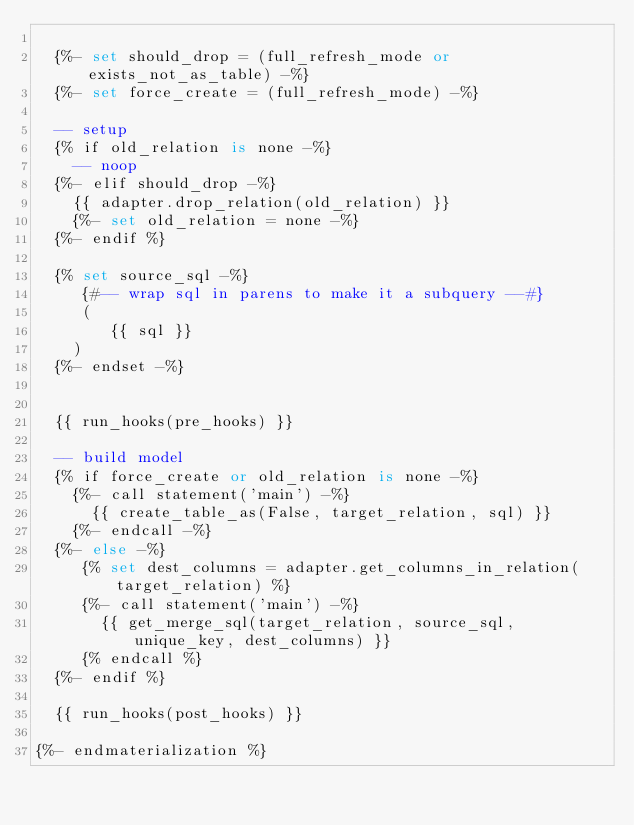Convert code to text. <code><loc_0><loc_0><loc_500><loc_500><_SQL_>
  {%- set should_drop = (full_refresh_mode or exists_not_as_table) -%}
  {%- set force_create = (full_refresh_mode) -%}

  -- setup
  {% if old_relation is none -%}
    -- noop
  {%- elif should_drop -%}
    {{ adapter.drop_relation(old_relation) }}
    {%- set old_relation = none -%}
  {%- endif %}

  {% set source_sql -%}
     {#-- wrap sql in parens to make it a subquery --#}
     (
        {{ sql }}
    )
  {%- endset -%}


  {{ run_hooks(pre_hooks) }}

  -- build model
  {% if force_create or old_relation is none -%}
    {%- call statement('main') -%}
      {{ create_table_as(False, target_relation, sql) }}
    {%- endcall -%}
  {%- else -%}
     {% set dest_columns = adapter.get_columns_in_relation(target_relation) %}
     {%- call statement('main') -%}
       {{ get_merge_sql(target_relation, source_sql, unique_key, dest_columns) }}
     {% endcall %}
  {%- endif %}

  {{ run_hooks(post_hooks) }}

{%- endmaterialization %}
</code> 